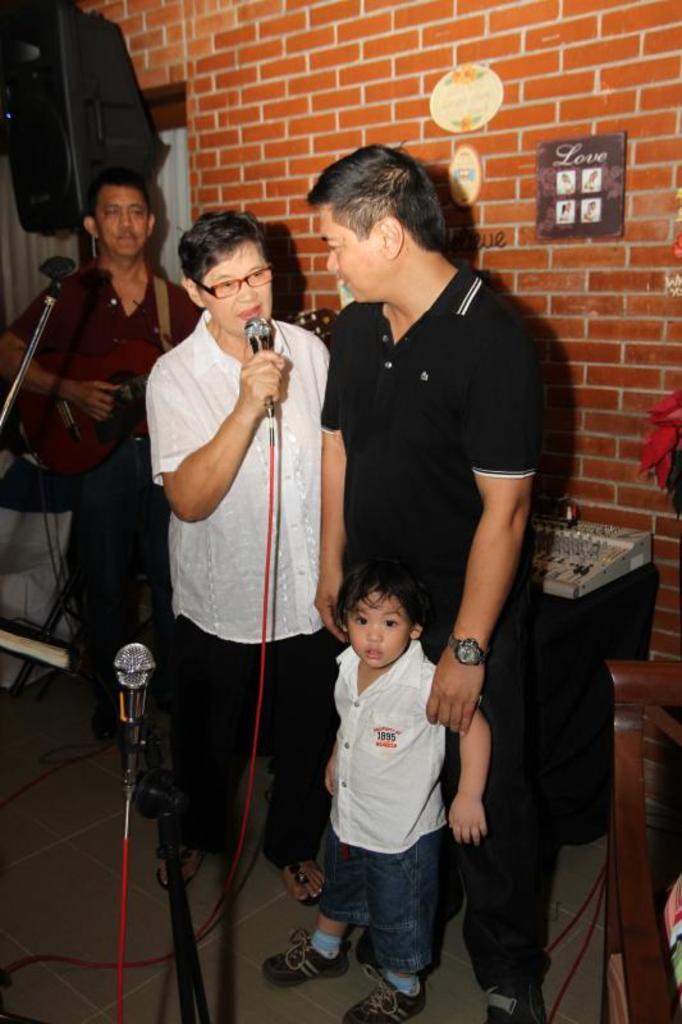How would you summarize this image in a sentence or two? In this picture there are three members and a kid standing. The guy in the middle is holding a mic in his hand. In the background there is a wall. 